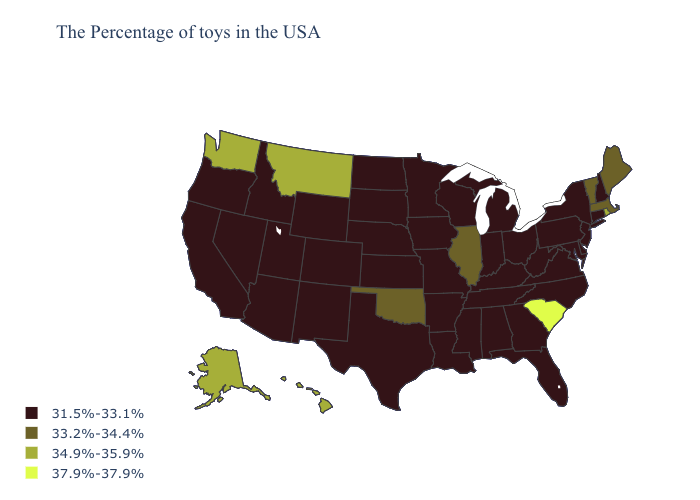Among the states that border Utah , which have the highest value?
Short answer required. Wyoming, Colorado, New Mexico, Arizona, Idaho, Nevada. Name the states that have a value in the range 31.5%-33.1%?
Answer briefly. New Hampshire, Connecticut, New York, New Jersey, Delaware, Maryland, Pennsylvania, Virginia, North Carolina, West Virginia, Ohio, Florida, Georgia, Michigan, Kentucky, Indiana, Alabama, Tennessee, Wisconsin, Mississippi, Louisiana, Missouri, Arkansas, Minnesota, Iowa, Kansas, Nebraska, Texas, South Dakota, North Dakota, Wyoming, Colorado, New Mexico, Utah, Arizona, Idaho, Nevada, California, Oregon. Name the states that have a value in the range 34.9%-35.9%?
Quick response, please. Rhode Island, Montana, Washington, Alaska, Hawaii. How many symbols are there in the legend?
Answer briefly. 4. Among the states that border Colorado , which have the highest value?
Write a very short answer. Oklahoma. Name the states that have a value in the range 37.9%-37.9%?
Write a very short answer. South Carolina. What is the value of Connecticut?
Give a very brief answer. 31.5%-33.1%. What is the lowest value in the MidWest?
Keep it brief. 31.5%-33.1%. Name the states that have a value in the range 31.5%-33.1%?
Write a very short answer. New Hampshire, Connecticut, New York, New Jersey, Delaware, Maryland, Pennsylvania, Virginia, North Carolina, West Virginia, Ohio, Florida, Georgia, Michigan, Kentucky, Indiana, Alabama, Tennessee, Wisconsin, Mississippi, Louisiana, Missouri, Arkansas, Minnesota, Iowa, Kansas, Nebraska, Texas, South Dakota, North Dakota, Wyoming, Colorado, New Mexico, Utah, Arizona, Idaho, Nevada, California, Oregon. What is the value of Alabama?
Concise answer only. 31.5%-33.1%. Does South Carolina have the highest value in the South?
Short answer required. Yes. Name the states that have a value in the range 33.2%-34.4%?
Give a very brief answer. Maine, Massachusetts, Vermont, Illinois, Oklahoma. Does the first symbol in the legend represent the smallest category?
Be succinct. Yes. Among the states that border West Virginia , which have the lowest value?
Concise answer only. Maryland, Pennsylvania, Virginia, Ohio, Kentucky. What is the value of North Carolina?
Answer briefly. 31.5%-33.1%. 